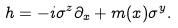<formula> <loc_0><loc_0><loc_500><loc_500>h = - i \sigma ^ { z } \partial _ { x } + m ( x ) \sigma ^ { y } .</formula> 